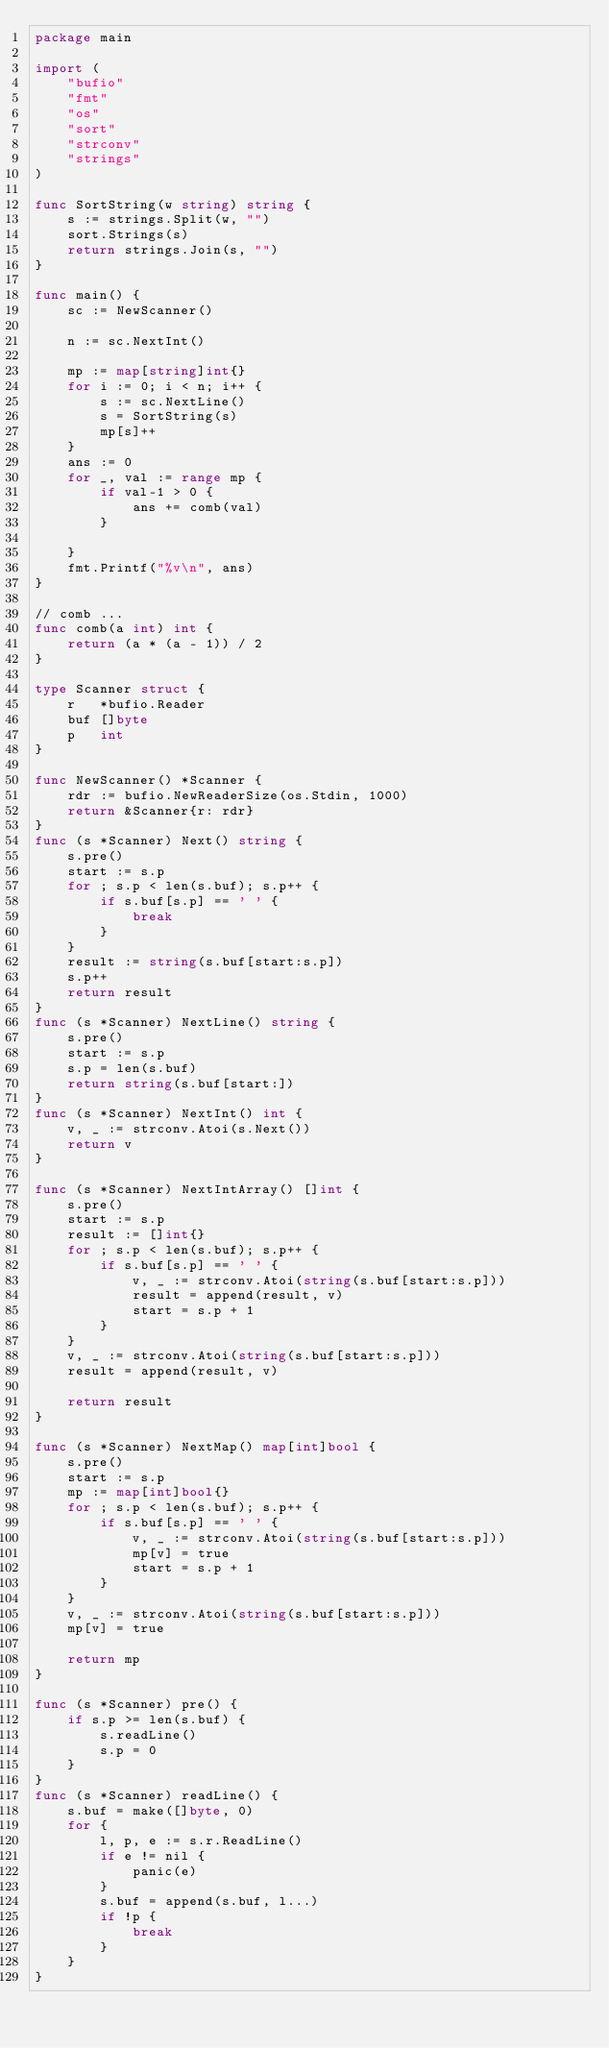<code> <loc_0><loc_0><loc_500><loc_500><_Go_>package main

import (
	"bufio"
	"fmt"
	"os"
	"sort"
	"strconv"
	"strings"
)

func SortString(w string) string {
	s := strings.Split(w, "")
	sort.Strings(s)
	return strings.Join(s, "")
}

func main() {
	sc := NewScanner()

	n := sc.NextInt()

	mp := map[string]int{}
	for i := 0; i < n; i++ {
		s := sc.NextLine()
		s = SortString(s)
		mp[s]++
	}
	ans := 0
	for _, val := range mp {
		if val-1 > 0 {
			ans += comb(val)
		}

	}
	fmt.Printf("%v\n", ans)
}

// comb ...
func comb(a int) int {
	return (a * (a - 1)) / 2
}

type Scanner struct {
	r   *bufio.Reader
	buf []byte
	p   int
}

func NewScanner() *Scanner {
	rdr := bufio.NewReaderSize(os.Stdin, 1000)
	return &Scanner{r: rdr}
}
func (s *Scanner) Next() string {
	s.pre()
	start := s.p
	for ; s.p < len(s.buf); s.p++ {
		if s.buf[s.p] == ' ' {
			break
		}
	}
	result := string(s.buf[start:s.p])
	s.p++
	return result
}
func (s *Scanner) NextLine() string {
	s.pre()
	start := s.p
	s.p = len(s.buf)
	return string(s.buf[start:])
}
func (s *Scanner) NextInt() int {
	v, _ := strconv.Atoi(s.Next())
	return v
}

func (s *Scanner) NextIntArray() []int {
	s.pre()
	start := s.p
	result := []int{}
	for ; s.p < len(s.buf); s.p++ {
		if s.buf[s.p] == ' ' {
			v, _ := strconv.Atoi(string(s.buf[start:s.p]))
			result = append(result, v)
			start = s.p + 1
		}
	}
	v, _ := strconv.Atoi(string(s.buf[start:s.p]))
	result = append(result, v)

	return result
}

func (s *Scanner) NextMap() map[int]bool {
	s.pre()
	start := s.p
	mp := map[int]bool{}
	for ; s.p < len(s.buf); s.p++ {
		if s.buf[s.p] == ' ' {
			v, _ := strconv.Atoi(string(s.buf[start:s.p]))
			mp[v] = true
			start = s.p + 1
		}
	}
	v, _ := strconv.Atoi(string(s.buf[start:s.p]))
	mp[v] = true

	return mp
}

func (s *Scanner) pre() {
	if s.p >= len(s.buf) {
		s.readLine()
		s.p = 0
	}
}
func (s *Scanner) readLine() {
	s.buf = make([]byte, 0)
	for {
		l, p, e := s.r.ReadLine()
		if e != nil {
			panic(e)
		}
		s.buf = append(s.buf, l...)
		if !p {
			break
		}
	}
}
</code> 